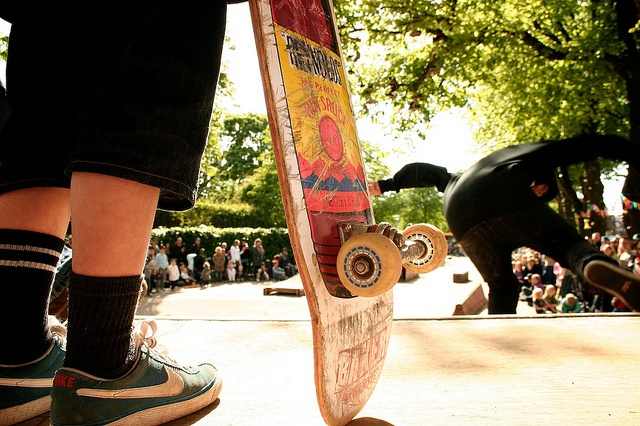Describe the objects in this image and their specific colors. I can see people in black, brown, tan, and maroon tones, skateboard in black, tan, and brown tones, people in black, gray, maroon, and olive tones, people in black, maroon, and gray tones, and people in black, maroon, and gray tones in this image. 